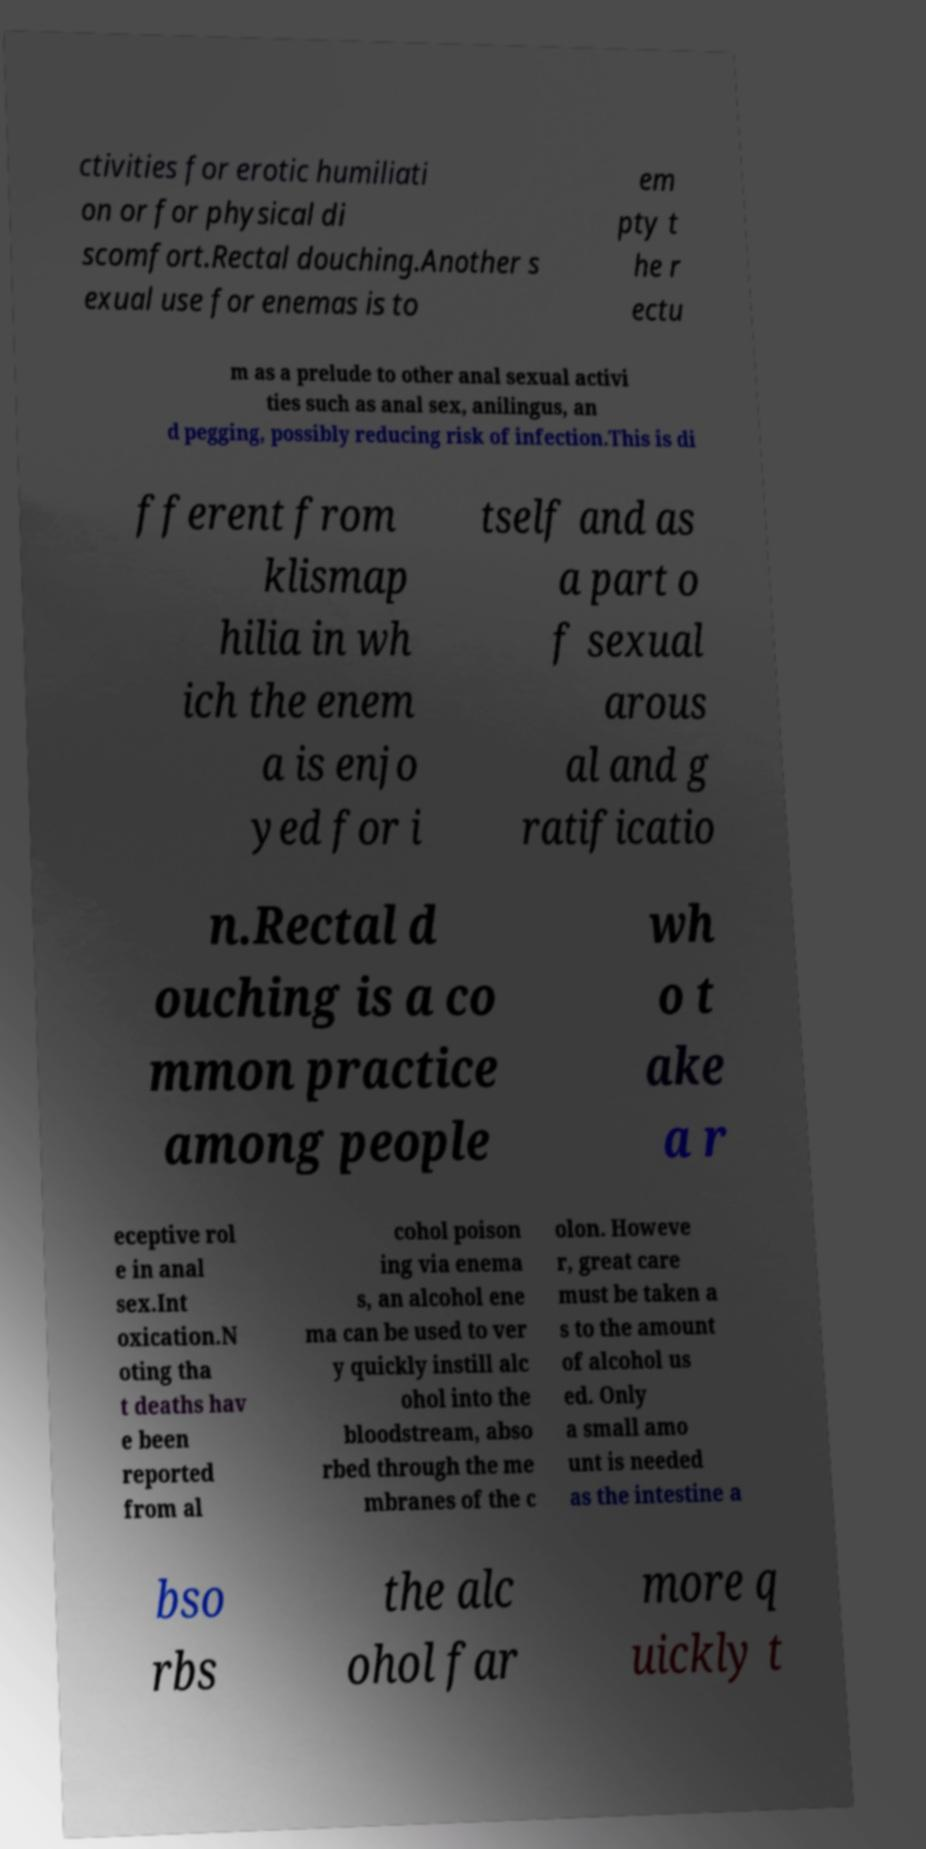For documentation purposes, I need the text within this image transcribed. Could you provide that? ctivities for erotic humiliati on or for physical di scomfort.Rectal douching.Another s exual use for enemas is to em pty t he r ectu m as a prelude to other anal sexual activi ties such as anal sex, anilingus, an d pegging, possibly reducing risk of infection.This is di fferent from klismap hilia in wh ich the enem a is enjo yed for i tself and as a part o f sexual arous al and g ratificatio n.Rectal d ouching is a co mmon practice among people wh o t ake a r eceptive rol e in anal sex.Int oxication.N oting tha t deaths hav e been reported from al cohol poison ing via enema s, an alcohol ene ma can be used to ver y quickly instill alc ohol into the bloodstream, abso rbed through the me mbranes of the c olon. Howeve r, great care must be taken a s to the amount of alcohol us ed. Only a small amo unt is needed as the intestine a bso rbs the alc ohol far more q uickly t 